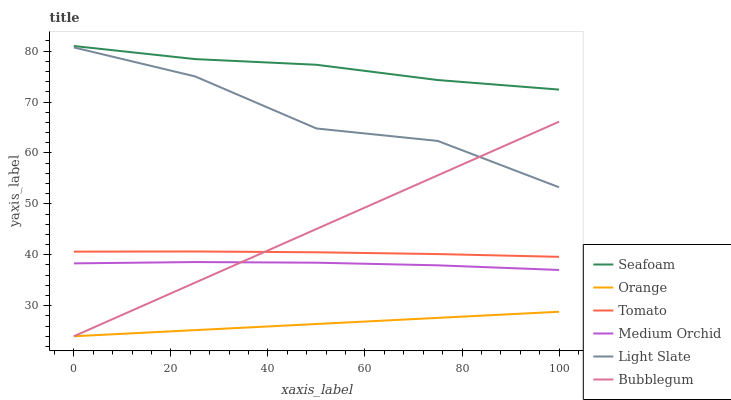Does Orange have the minimum area under the curve?
Answer yes or no. Yes. Does Seafoam have the maximum area under the curve?
Answer yes or no. Yes. Does Light Slate have the minimum area under the curve?
Answer yes or no. No. Does Light Slate have the maximum area under the curve?
Answer yes or no. No. Is Bubblegum the smoothest?
Answer yes or no. Yes. Is Light Slate the roughest?
Answer yes or no. Yes. Is Medium Orchid the smoothest?
Answer yes or no. No. Is Medium Orchid the roughest?
Answer yes or no. No. Does Bubblegum have the lowest value?
Answer yes or no. Yes. Does Light Slate have the lowest value?
Answer yes or no. No. Does Seafoam have the highest value?
Answer yes or no. Yes. Does Light Slate have the highest value?
Answer yes or no. No. Is Bubblegum less than Seafoam?
Answer yes or no. Yes. Is Seafoam greater than Medium Orchid?
Answer yes or no. Yes. Does Bubblegum intersect Light Slate?
Answer yes or no. Yes. Is Bubblegum less than Light Slate?
Answer yes or no. No. Is Bubblegum greater than Light Slate?
Answer yes or no. No. Does Bubblegum intersect Seafoam?
Answer yes or no. No. 